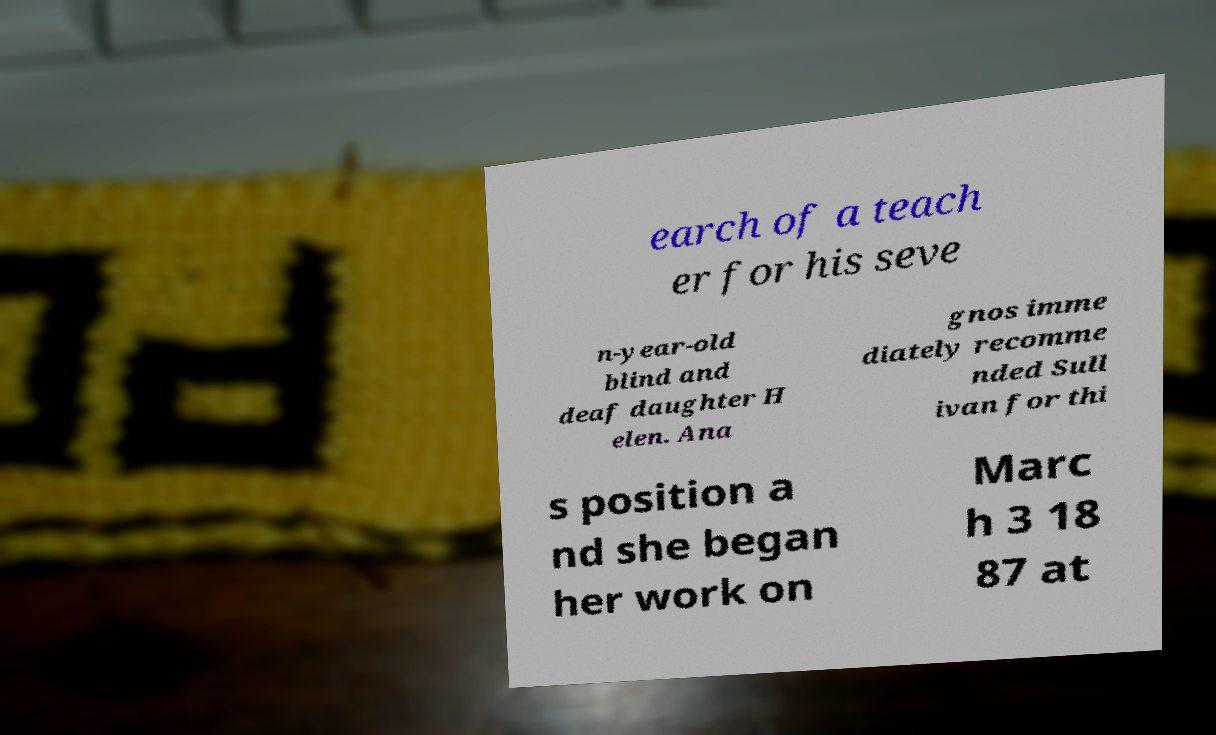I need the written content from this picture converted into text. Can you do that? earch of a teach er for his seve n-year-old blind and deaf daughter H elen. Ana gnos imme diately recomme nded Sull ivan for thi s position a nd she began her work on Marc h 3 18 87 at 